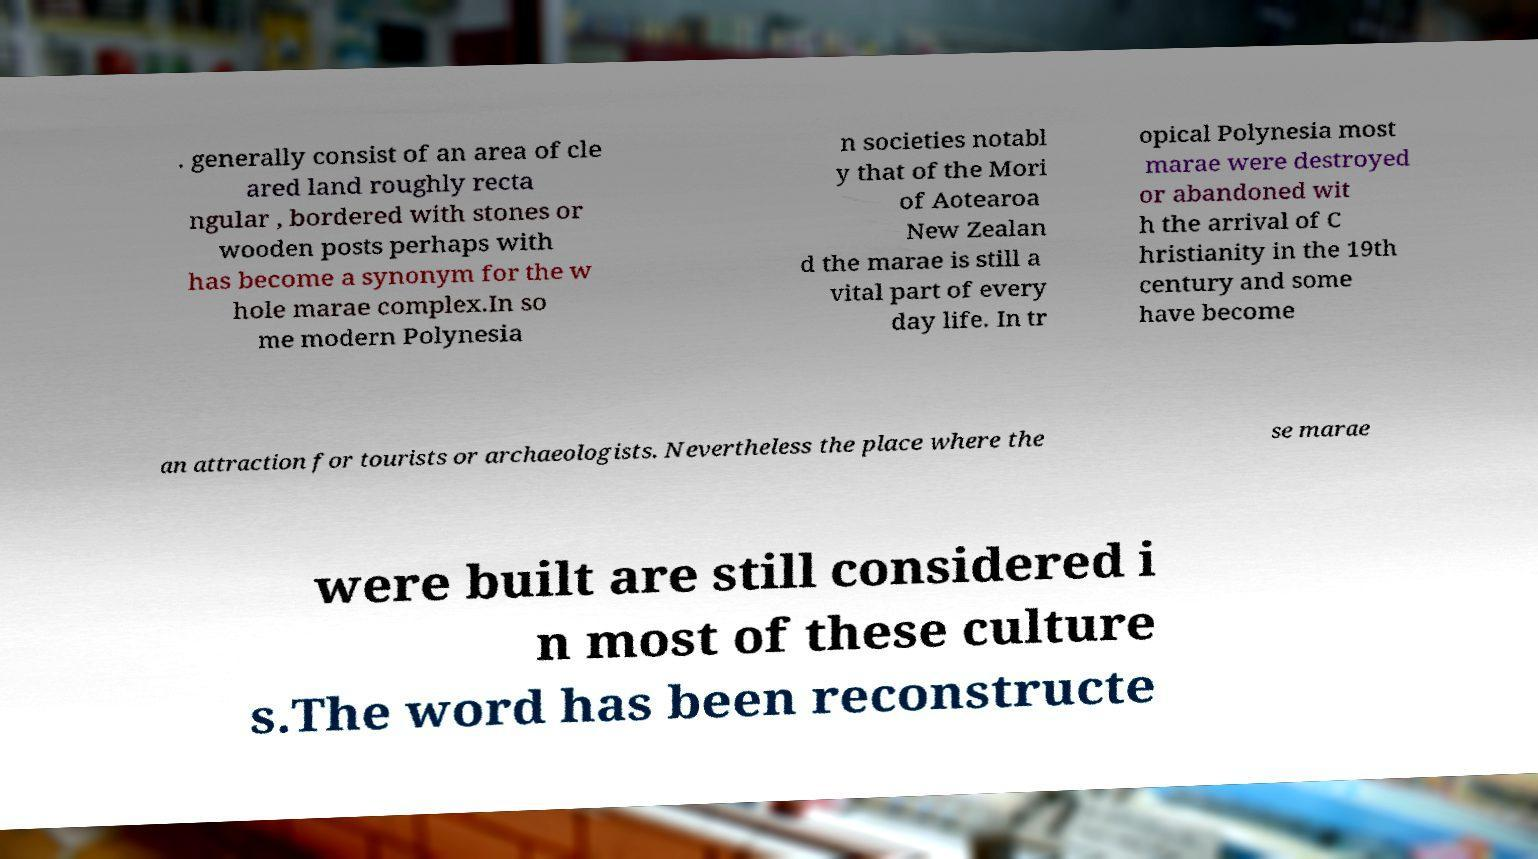Please identify and transcribe the text found in this image. . generally consist of an area of cle ared land roughly recta ngular , bordered with stones or wooden posts perhaps with has become a synonym for the w hole marae complex.In so me modern Polynesia n societies notabl y that of the Mori of Aotearoa New Zealan d the marae is still a vital part of every day life. In tr opical Polynesia most marae were destroyed or abandoned wit h the arrival of C hristianity in the 19th century and some have become an attraction for tourists or archaeologists. Nevertheless the place where the se marae were built are still considered i n most of these culture s.The word has been reconstructe 